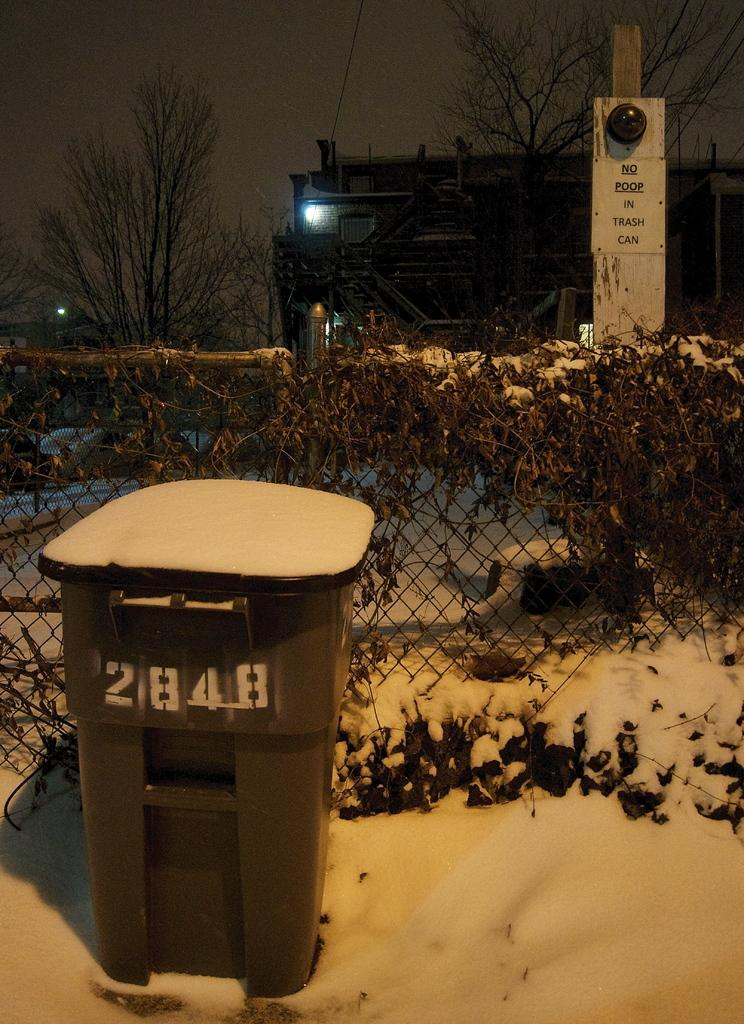Provide a one-sentence caption for the provided image. A trash can is sitting in the snow with a # 2848. 